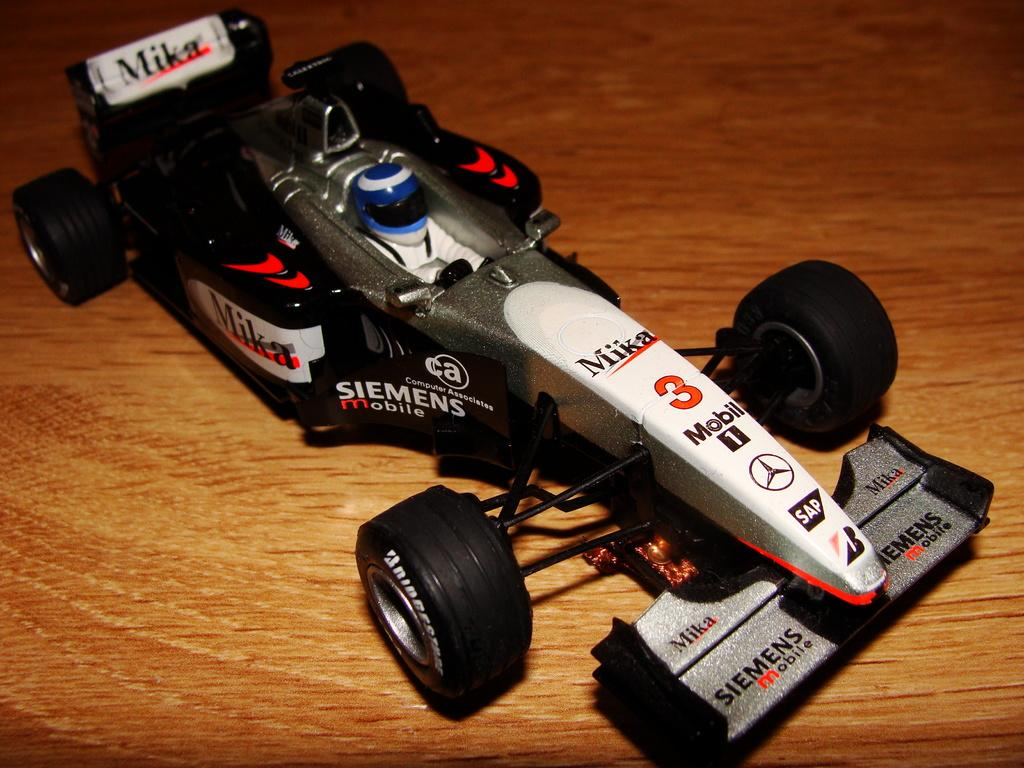What type of vehicle is present in the image? There is a black color car toy in the image. What direction is the pig facing in the image? There is no pig present in the image; it features a black color car toy. 